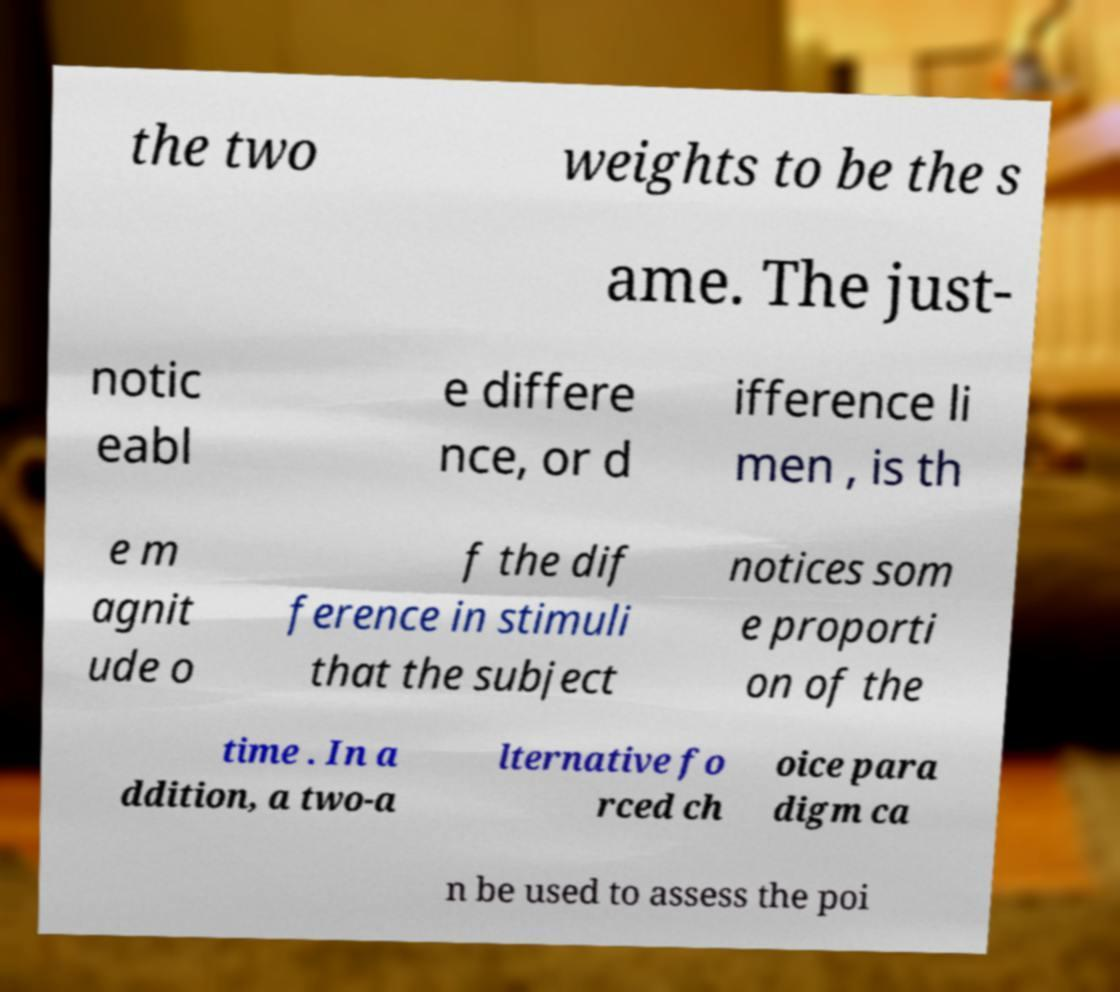For documentation purposes, I need the text within this image transcribed. Could you provide that? the two weights to be the s ame. The just- notic eabl e differe nce, or d ifference li men , is th e m agnit ude o f the dif ference in stimuli that the subject notices som e proporti on of the time . In a ddition, a two-a lternative fo rced ch oice para digm ca n be used to assess the poi 